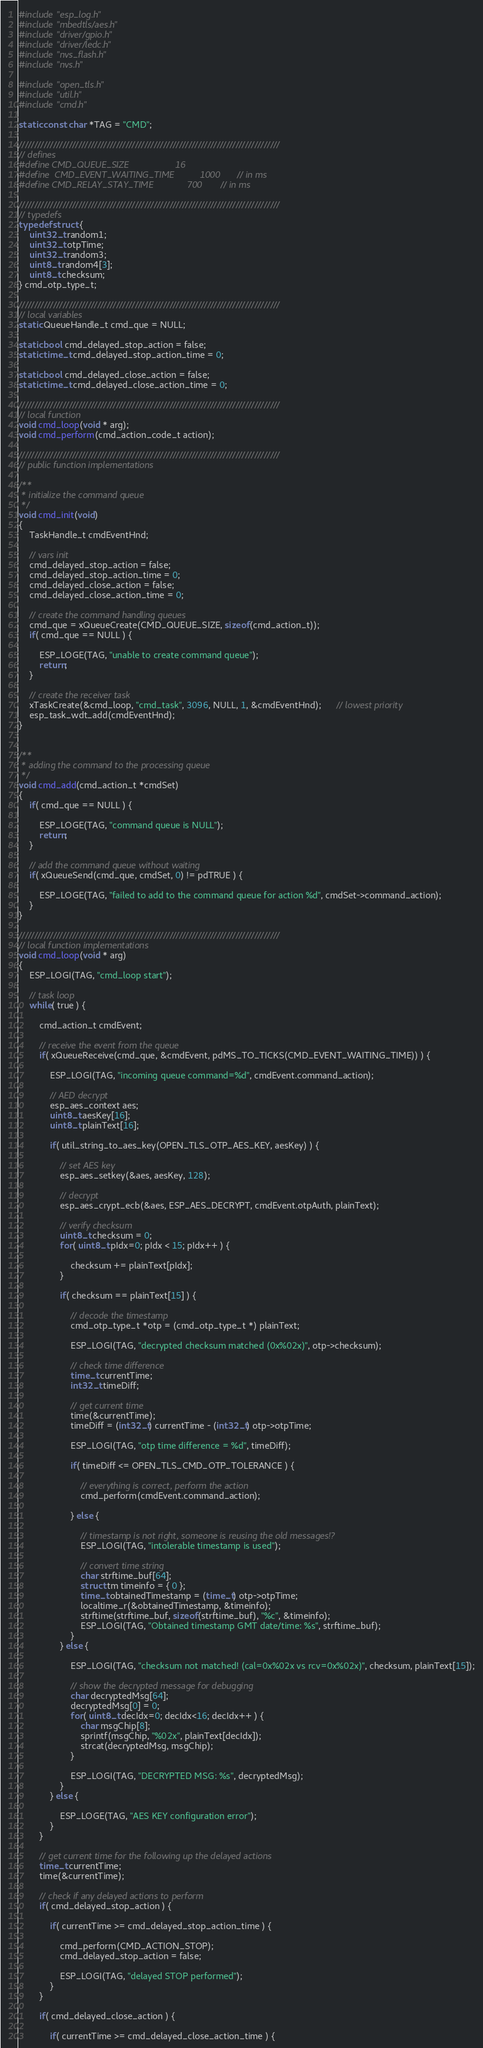<code> <loc_0><loc_0><loc_500><loc_500><_C_>#include "esp_log.h"
#include "mbedtls/aes.h"
#include "driver/gpio.h"
#include "driver/ledc.h"
#include "nvs_flash.h"
#include "nvs.h"

#include "open_tls.h"
#include "util.h"
#include "cmd.h"

static const char *TAG = "CMD";

///////////////////////////////////////////////////////////////////////////////////
// defines
#define CMD_QUEUE_SIZE                  16
#define	CMD_EVENT_WAITING_TIME			1000	// in ms
#define CMD_RELAY_STAY_TIME             700     // in ms

///////////////////////////////////////////////////////////////////////////////////
// typedefs
typedef struct {
    uint32_t random1;
    uint32_t otpTime;
    uint32_t random3;
    uint8_t random4[3];
    uint8_t checksum;
} cmd_otp_type_t;

///////////////////////////////////////////////////////////////////////////////////
// local variables
static QueueHandle_t cmd_que = NULL;

static bool cmd_delayed_stop_action = false;
static time_t cmd_delayed_stop_action_time = 0;

static bool cmd_delayed_close_action = false;
static time_t cmd_delayed_close_action_time = 0;

///////////////////////////////////////////////////////////////////////////////////
// local function
void cmd_loop(void * arg);
void cmd_perform(cmd_action_code_t action);

///////////////////////////////////////////////////////////////////////////////////
// public function implementations

/**
 * initialize the command queue
 */
void cmd_init(void)
{
    TaskHandle_t cmdEventHnd;

    // vars init
    cmd_delayed_stop_action = false;
    cmd_delayed_stop_action_time = 0;
    cmd_delayed_close_action = false;
    cmd_delayed_close_action_time = 0;

    // create the command handling queues
    cmd_que = xQueueCreate(CMD_QUEUE_SIZE, sizeof(cmd_action_t));
    if( cmd_que == NULL ) {

        ESP_LOGE(TAG, "unable to create command queue");
        return;
    }

	// create the receiver task
	xTaskCreate(&cmd_loop, "cmd_task", 3096, NULL, 1, &cmdEventHnd);	  // lowest priority
	esp_task_wdt_add(cmdEventHnd);
}


/**
 * adding the command to the processing queue
 */
void cmd_add(cmd_action_t *cmdSet)
{
    if( cmd_que == NULL ) {

        ESP_LOGE(TAG, "command queue is NULL");
        return;
    }

    // add the command queue without waiting
    if( xQueueSend(cmd_que, cmdSet, 0) != pdTRUE ) {

        ESP_LOGE(TAG, "failed to add to the command queue for action %d", cmdSet->command_action);
    }
}

///////////////////////////////////////////////////////////////////////////////////
// local function implementations
void cmd_loop(void * arg)
{
	ESP_LOGI(TAG, "cmd_loop start");

	// task loop
	while( true ) {

        cmd_action_t cmdEvent;

		// receive the event from the queue
		if( xQueueReceive(cmd_que, &cmdEvent, pdMS_TO_TICKS(CMD_EVENT_WAITING_TIME)) ) {

            ESP_LOGI(TAG, "incoming queue command=%d", cmdEvent.command_action);

            // AED decrypt
            esp_aes_context aes;
            uint8_t aesKey[16];
            uint8_t plainText[16];

            if( util_string_to_aes_key(OPEN_TLS_OTP_AES_KEY, aesKey) ) {

                // set AES key
                esp_aes_setkey(&aes, aesKey, 128);

                // decrypt
                esp_aes_crypt_ecb(&aes, ESP_AES_DECRYPT, cmdEvent.otpAuth, plainText);

                // verify checksum
                uint8_t checksum = 0;
                for( uint8_t pIdx=0; pIdx < 15; pIdx++ ) {

                    checksum += plainText[pIdx];
                }

                if( checksum == plainText[15] ) {

                    // decode the timestamp
                    cmd_otp_type_t *otp = (cmd_otp_type_t *) plainText;

                    ESP_LOGI(TAG, "decrypted checksum matched (0x%02x)", otp->checksum);

                    // check time difference
                    time_t currentTime;
                    int32_t timeDiff;

                    // get current time
                    time(&currentTime);
                    timeDiff = (int32_t) currentTime - (int32_t) otp->otpTime;

                    ESP_LOGI(TAG, "otp time difference = %d", timeDiff);

                    if( timeDiff <= OPEN_TLS_CMD_OTP_TOLERANCE ) {

                        // everything is correct, perform the action
                        cmd_perform(cmdEvent.command_action);

                    } else {

                        // timestamp is not right, someone is reusing the old messages!?
                        ESP_LOGI(TAG, "intolerable timestamp is used");

                        // convert time string
                        char strftime_buf[64];
                        struct tm timeinfo = { 0 };
                        time_t obtainedTimestamp = (time_t) otp->otpTime;
                        localtime_r(&obtainedTimestamp, &timeinfo);
                        strftime(strftime_buf, sizeof(strftime_buf), "%c", &timeinfo);
                        ESP_LOGI(TAG, "Obtained timestamp GMT date/time: %s", strftime_buf);
                    }
                } else {

                    ESP_LOGI(TAG, "checksum not matched! (cal=0x%02x vs rcv=0x%02x)", checksum, plainText[15]);

                    // show the decrypted message for debugging
                    char decryptedMsg[64];
                    decryptedMsg[0] = 0;
                    for( uint8_t decIdx=0; decIdx<16; decIdx++ ) {
                        char msgChip[8];
                        sprintf(msgChip, "%02x", plainText[decIdx]);
                        strcat(decryptedMsg, msgChip);
                    }

                    ESP_LOGI(TAG, "DECRYPTED MSG: %s", decryptedMsg);
                }
            } else {

                ESP_LOGE(TAG, "AES KEY configuration error");
            }
        }

        // get current time for the following up the delayed actions
        time_t currentTime;
        time(&currentTime);

        // check if any delayed actions to perform
        if( cmd_delayed_stop_action ) {

            if( currentTime >= cmd_delayed_stop_action_time ) {

                cmd_perform(CMD_ACTION_STOP);
                cmd_delayed_stop_action = false;

                ESP_LOGI(TAG, "delayed STOP performed");
            }
        }

        if( cmd_delayed_close_action ) {

            if( currentTime >= cmd_delayed_close_action_time ) {
</code> 